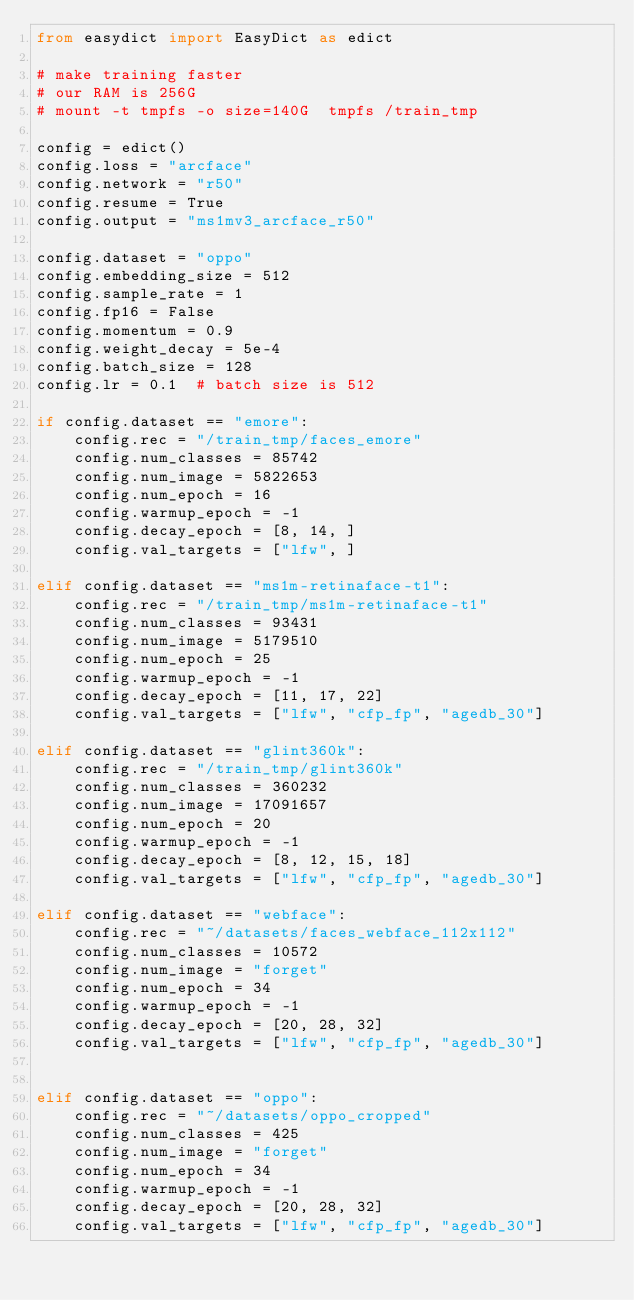Convert code to text. <code><loc_0><loc_0><loc_500><loc_500><_Python_>from easydict import EasyDict as edict

# make training faster
# our RAM is 256G
# mount -t tmpfs -o size=140G  tmpfs /train_tmp

config = edict()
config.loss = "arcface"
config.network = "r50"
config.resume = True
config.output = "ms1mv3_arcface_r50"

config.dataset = "oppo"
config.embedding_size = 512
config.sample_rate = 1
config.fp16 = False
config.momentum = 0.9
config.weight_decay = 5e-4
config.batch_size = 128
config.lr = 0.1  # batch size is 512

if config.dataset == "emore":
    config.rec = "/train_tmp/faces_emore"
    config.num_classes = 85742
    config.num_image = 5822653
    config.num_epoch = 16
    config.warmup_epoch = -1
    config.decay_epoch = [8, 14, ]
    config.val_targets = ["lfw", ]

elif config.dataset == "ms1m-retinaface-t1":
    config.rec = "/train_tmp/ms1m-retinaface-t1"
    config.num_classes = 93431
    config.num_image = 5179510
    config.num_epoch = 25
    config.warmup_epoch = -1
    config.decay_epoch = [11, 17, 22]
    config.val_targets = ["lfw", "cfp_fp", "agedb_30"]

elif config.dataset == "glint360k":
    config.rec = "/train_tmp/glint360k"
    config.num_classes = 360232
    config.num_image = 17091657
    config.num_epoch = 20
    config.warmup_epoch = -1
    config.decay_epoch = [8, 12, 15, 18]
    config.val_targets = ["lfw", "cfp_fp", "agedb_30"]

elif config.dataset == "webface":
    config.rec = "~/datasets/faces_webface_112x112"
    config.num_classes = 10572
    config.num_image = "forget"
    config.num_epoch = 34
    config.warmup_epoch = -1
    config.decay_epoch = [20, 28, 32]
    config.val_targets = ["lfw", "cfp_fp", "agedb_30"]


elif config.dataset == "oppo":
    config.rec = "~/datasets/oppo_cropped"
    config.num_classes = 425
    config.num_image = "forget"
    config.num_epoch = 34
    config.warmup_epoch = -1
    config.decay_epoch = [20, 28, 32]
    config.val_targets = ["lfw", "cfp_fp", "agedb_30"]</code> 